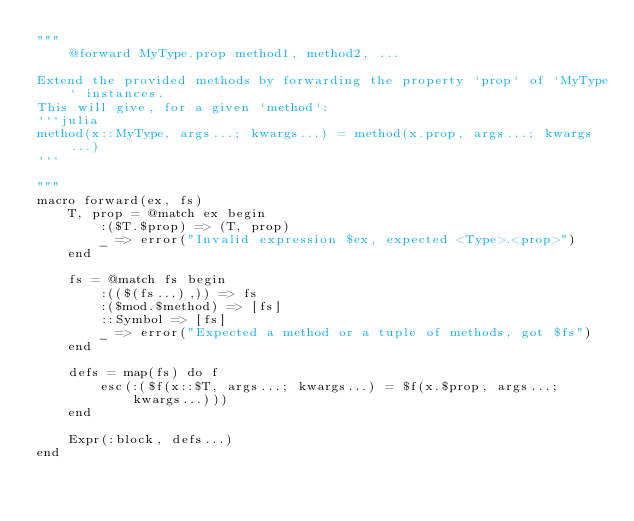<code> <loc_0><loc_0><loc_500><loc_500><_Julia_>"""
    @forward MyType.prop method1, method2, ...

Extend the provided methods by forwarding the property `prop` of `MyType` instances.
This will give, for a given `method`:
```julia
method(x::MyType, args...; kwargs...) = method(x.prop, args...; kwargs...)
```

"""
macro forward(ex, fs)
    T, prop = @match ex begin
        :($T.$prop) => (T, prop)
        _ => error("Invalid expression $ex, expected <Type>.<prop>")
    end

    fs = @match fs begin
        :(($(fs...),)) => fs
        :($mod.$method) => [fs]
        ::Symbol => [fs]
        _ => error("Expected a method or a tuple of methods, got $fs")
    end

    defs = map(fs) do f
        esc(:($f(x::$T, args...; kwargs...) = $f(x.$prop, args...; kwargs...)))
    end

    Expr(:block, defs...)
end
</code> 